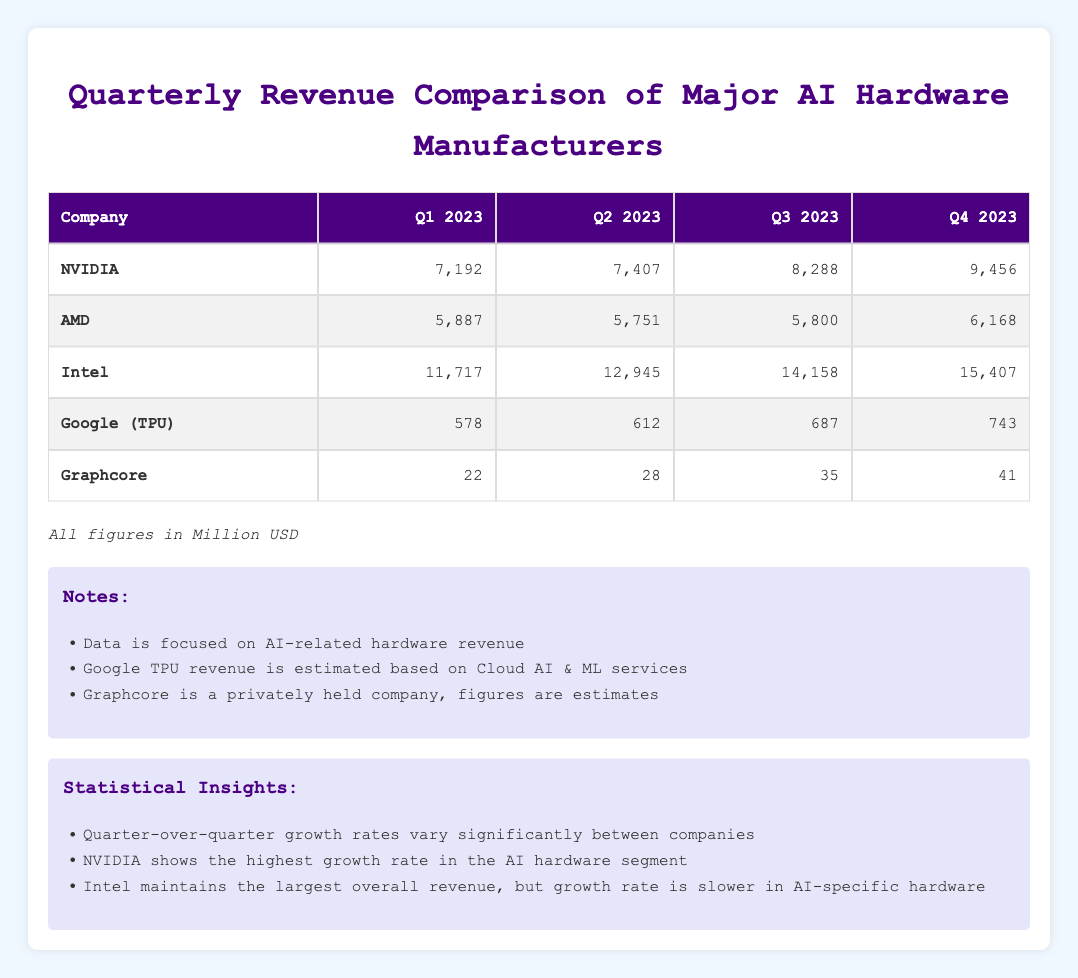What was Intel's revenue for Q4 2023? The table lists Intel's revenues, and for Q4 2023, the value shown is 15,407 million USD.
Answer: 15,407 million USD Which company had the lowest revenue in Q1 2023? By reviewing the Q1 2023 column, Graphcore shows the lowest revenue at 22 million USD compared to other companies listed.
Answer: Graphcore What is the total revenue for NVIDIA across all four quarters? To find the total revenue for NVIDIA, sum the values: 7,192 + 7,407 + 8,288 + 9,456 = 32,343 million USD.
Answer: 32,343 million USD Did Google (TPU) see an increase in revenue from Q1 to Q4 2023? Comparing the Q1 revenue of 578 million USD to the Q4 revenue of 743 million USD shows an increase, as 743 is greater than 578.
Answer: Yes What is the average revenue of AMD across all four quarters? The average revenue for AMD is calculated by summing the revenues (5,887 + 5,751 + 5,800 + 6,168 = 23,606) and dividing by the number of quarters (23,606 / 4 = 5,901.5 million USD).
Answer: 5,901.5 million USD Which company had the highest revenue growth from Q1 2023 to Q4 2023? To find the highest growth, calculate the difference for each company: NVIDIA (9,456 - 7,192), AMD (6,168 - 5,887), Intel (15,407 - 11,717), Google (TPU) (743 - 578), and Graphcore (41 - 22). Highest growth is NVIDIA: 2,264 million USD.
Answer: NVIDIA What was the revenue of Graphcore in Q3 2023? The revenue for Graphcore in Q3 2023 is directly provided in the table as 35 million USD.
Answer: 35 million USD Is NVIDIA's Q2 2023 revenue greater than Intel's Q1 2023 revenue? Comparing the values, NVIDIA's Q2 2023 revenue is 7,407 million USD and Intel's Q1 2023 revenue is 11,717 million USD. Since 7,407 is less than 11,717, the statement is false.
Answer: No What is the difference in revenue between Intel and AMD for Q3 2023? The difference can be found by subtracting AMD's Q3 (5,800 million USD) from Intel's Q3 (14,158 million USD): 14,158 - 5,800 = 8,358 million USD.
Answer: 8,358 million USD 